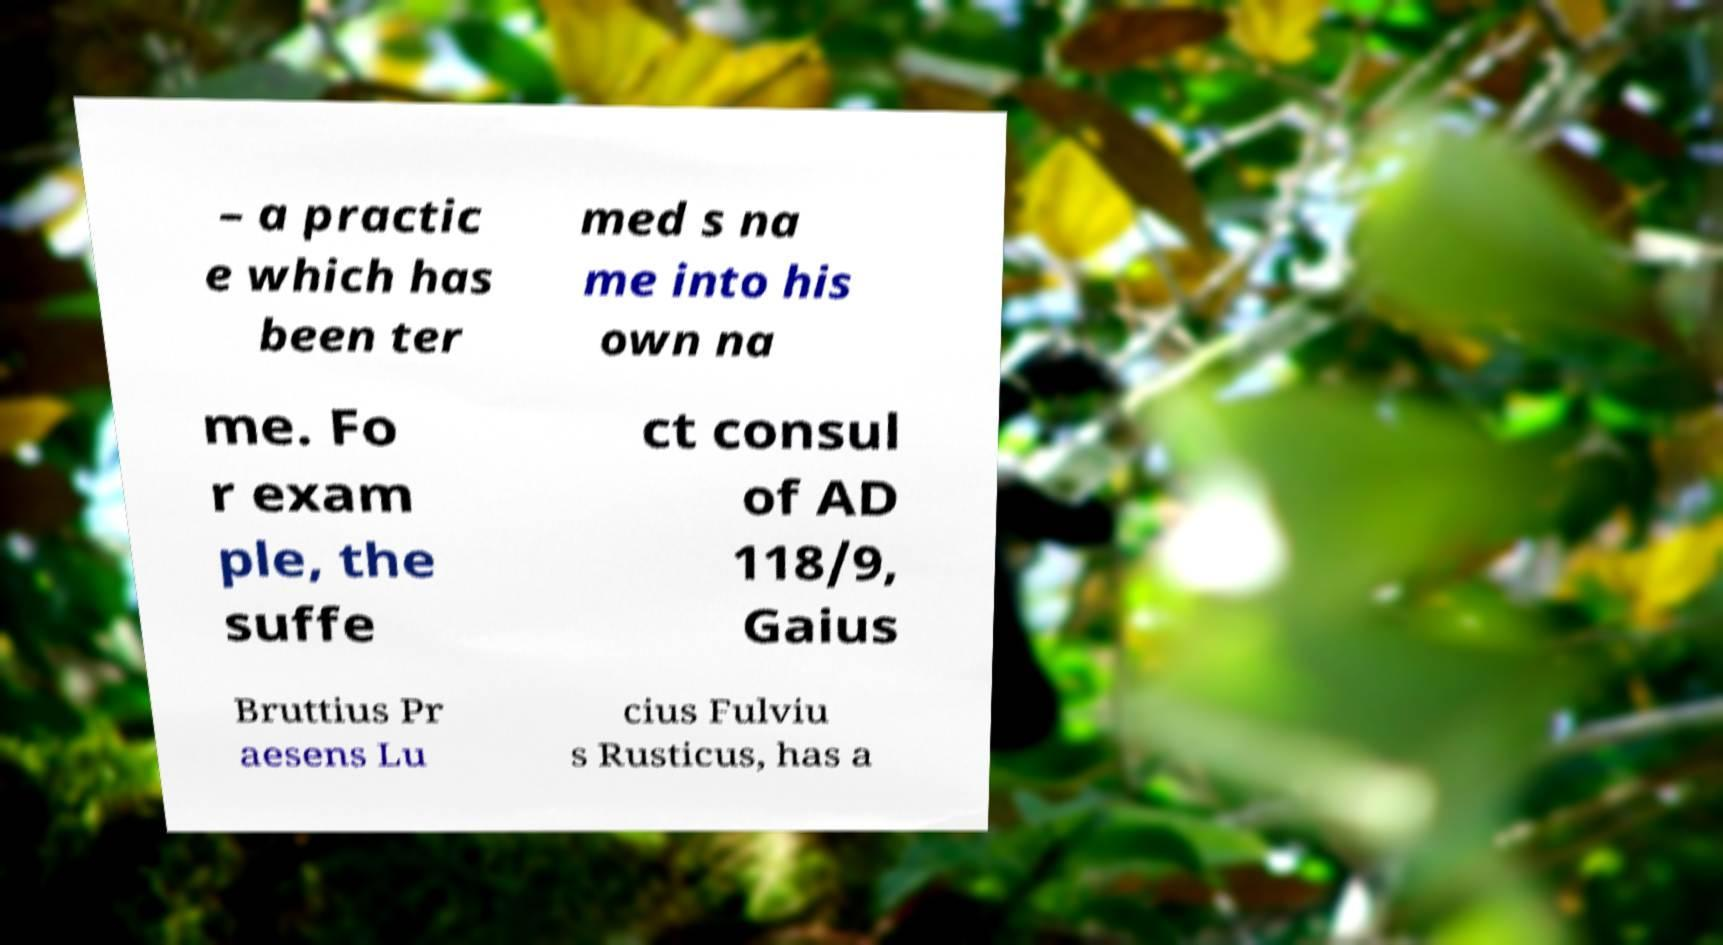Can you accurately transcribe the text from the provided image for me? – a practic e which has been ter med s na me into his own na me. Fo r exam ple, the suffe ct consul of AD 118/9, Gaius Bruttius Pr aesens Lu cius Fulviu s Rusticus, has a 